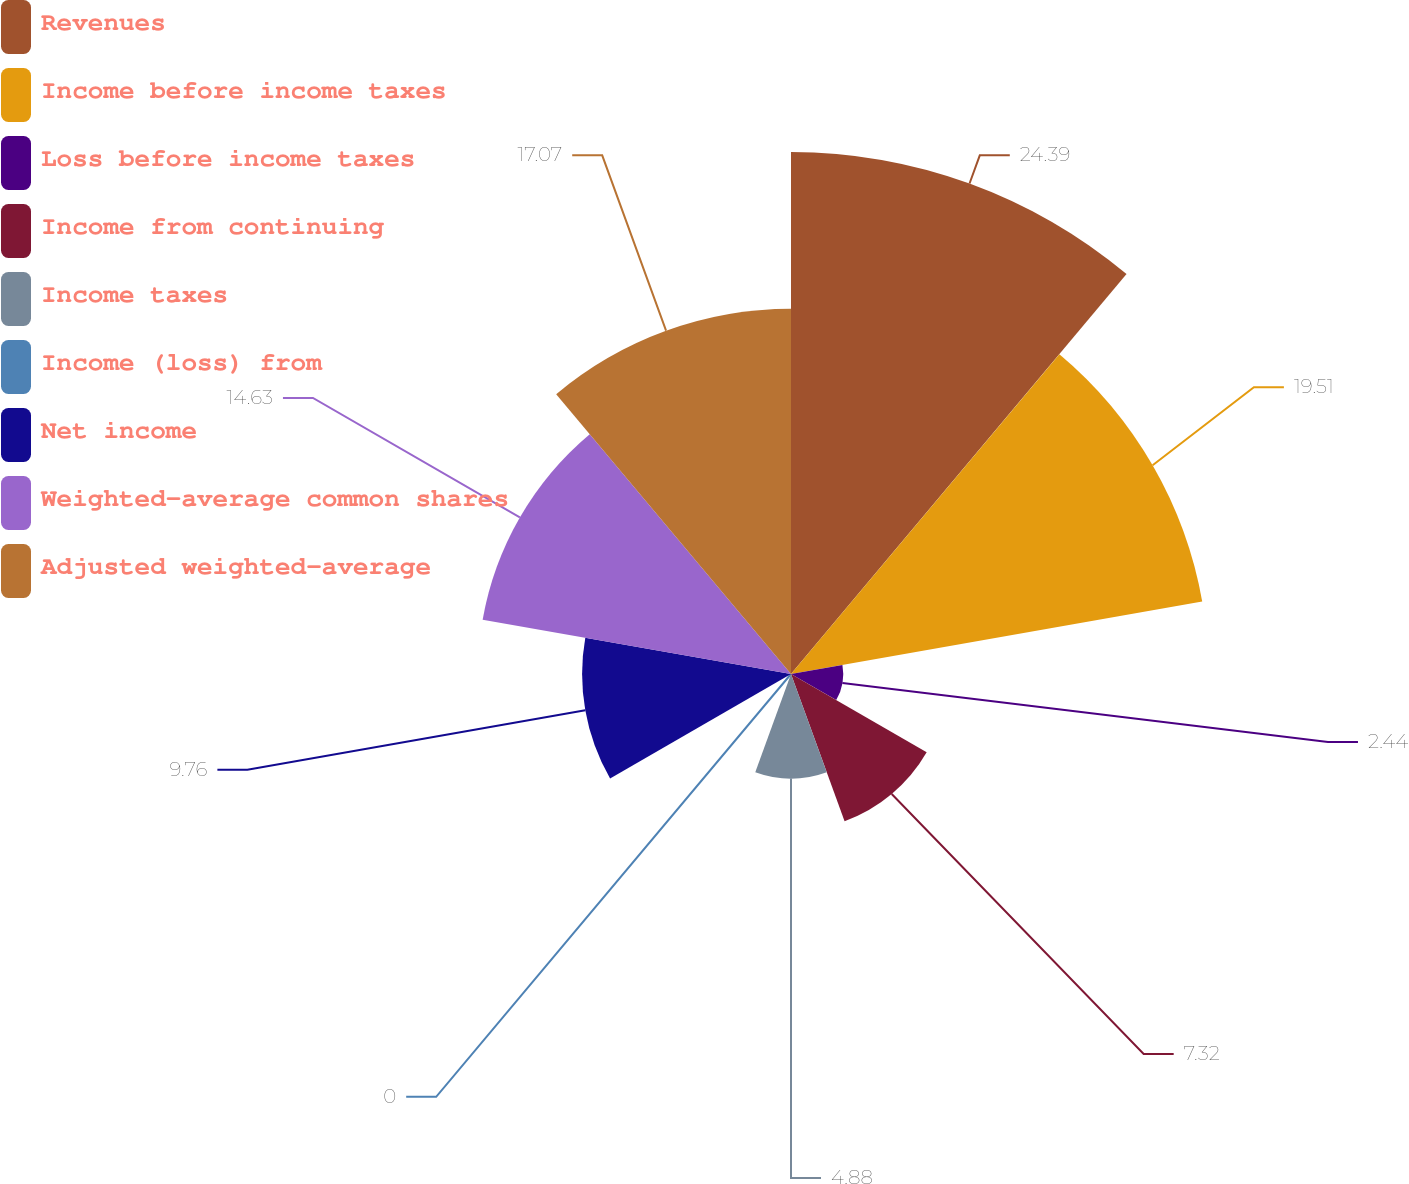Convert chart to OTSL. <chart><loc_0><loc_0><loc_500><loc_500><pie_chart><fcel>Revenues<fcel>Income before income taxes<fcel>Loss before income taxes<fcel>Income from continuing<fcel>Income taxes<fcel>Income (loss) from<fcel>Net income<fcel>Weighted-average common shares<fcel>Adjusted weighted-average<nl><fcel>24.39%<fcel>19.51%<fcel>2.44%<fcel>7.32%<fcel>4.88%<fcel>0.0%<fcel>9.76%<fcel>14.63%<fcel>17.07%<nl></chart> 